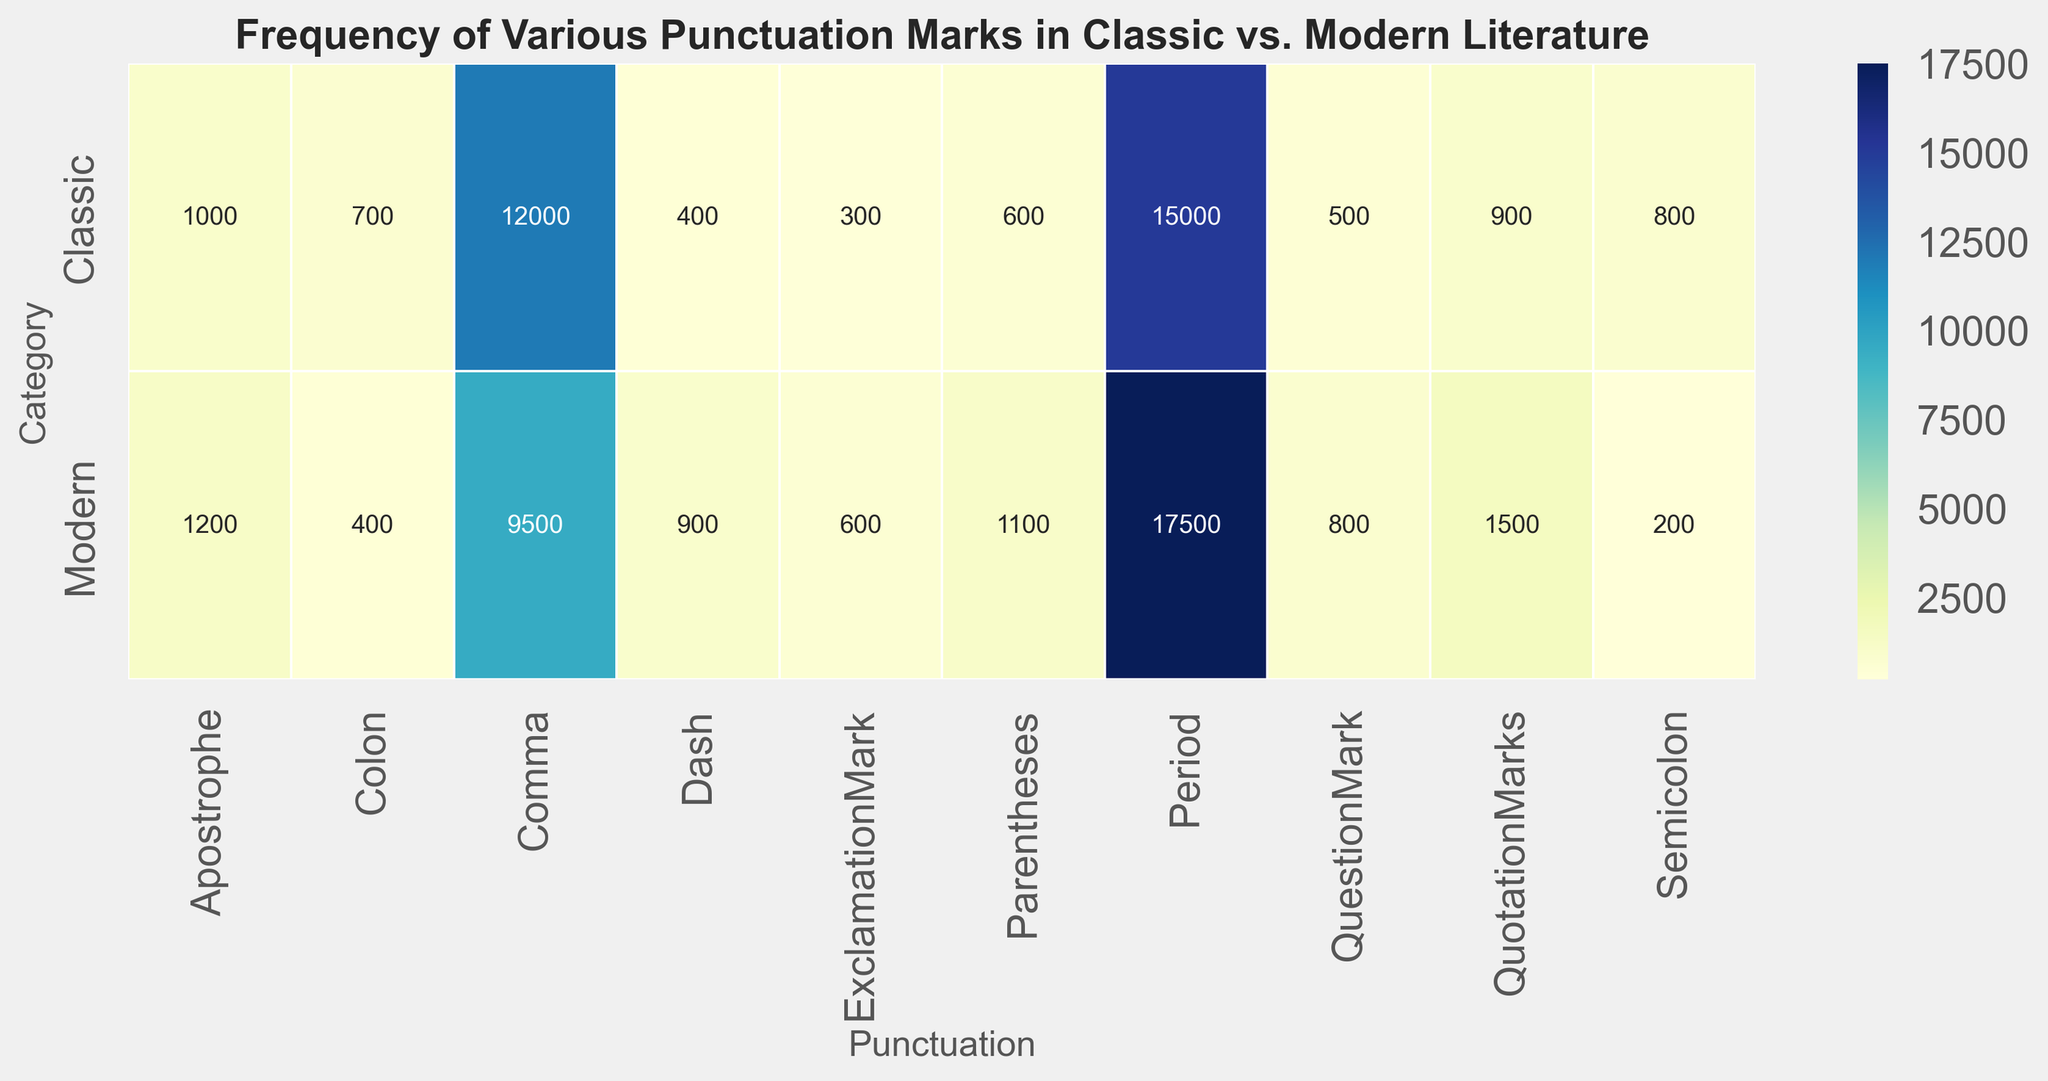What's the total count of commas in both Classic and Modern literature? To find this, locate the counts of commas for both Classic and Modern categories and add them up: 12,000 (Classic) + 9,500 (Modern) = 21,500
Answer: 21,500 Which category has a higher usage of exclamation marks? Compare the count of exclamation marks across both categories: Classic has 300, and Modern has 600. Since 600 > 300, Modern literature uses more exclamation marks.
Answer: Modern Are dashes used more frequently in Classic literature or Modern literature? By how much? Compare the counts of dashes in both categories: Classic has 400 and Modern has 900. Calculate the difference: 900 - 400 = 500.
Answer: Modern by 500 What's the visual pattern for parentheses usage across categories? Looking at the color intensity for parentheses, Modern has a slightly darker shade indicating a higher count (1,100) compared to Classic (600).
Answer: Modern uses more parentheses What's the difference in the number of periods between Classic and Modern literature? Subtract the count of periods in Classic from the count in Modern: 17,500 - 15,000 = 2,500
Answer: 2,500 Which punctuation mark has the smallest count in Modern literature? By observing the heatmap, you can see the lightest shade in the Modern row for Semicolon with a count of 200.
Answer: Semicolon How does the count of question marks compare between Classic and Modern literature? Classic literature has 500 question marks, and Modern literature has 800. Since 800 > 500, Modern literature has more, with a difference of 300.
Answer: Modern by 300 What's the combined count of colons and semicolons in Classic literature? Add the counts of colons and semicolons in Classic: 700 (colon) + 800 (semicolon) = 1,500
Answer: 1,500 Considering periods and commas together, which category has a higher combined count? Calculate the combined count for each: Classic has 15,000 (periods) + 12,000 (commas) = 27,000, and Modern has 17,500 (periods) + 9,500 (commas) = 27,000. Both are equal.
Answer: Both are equal 